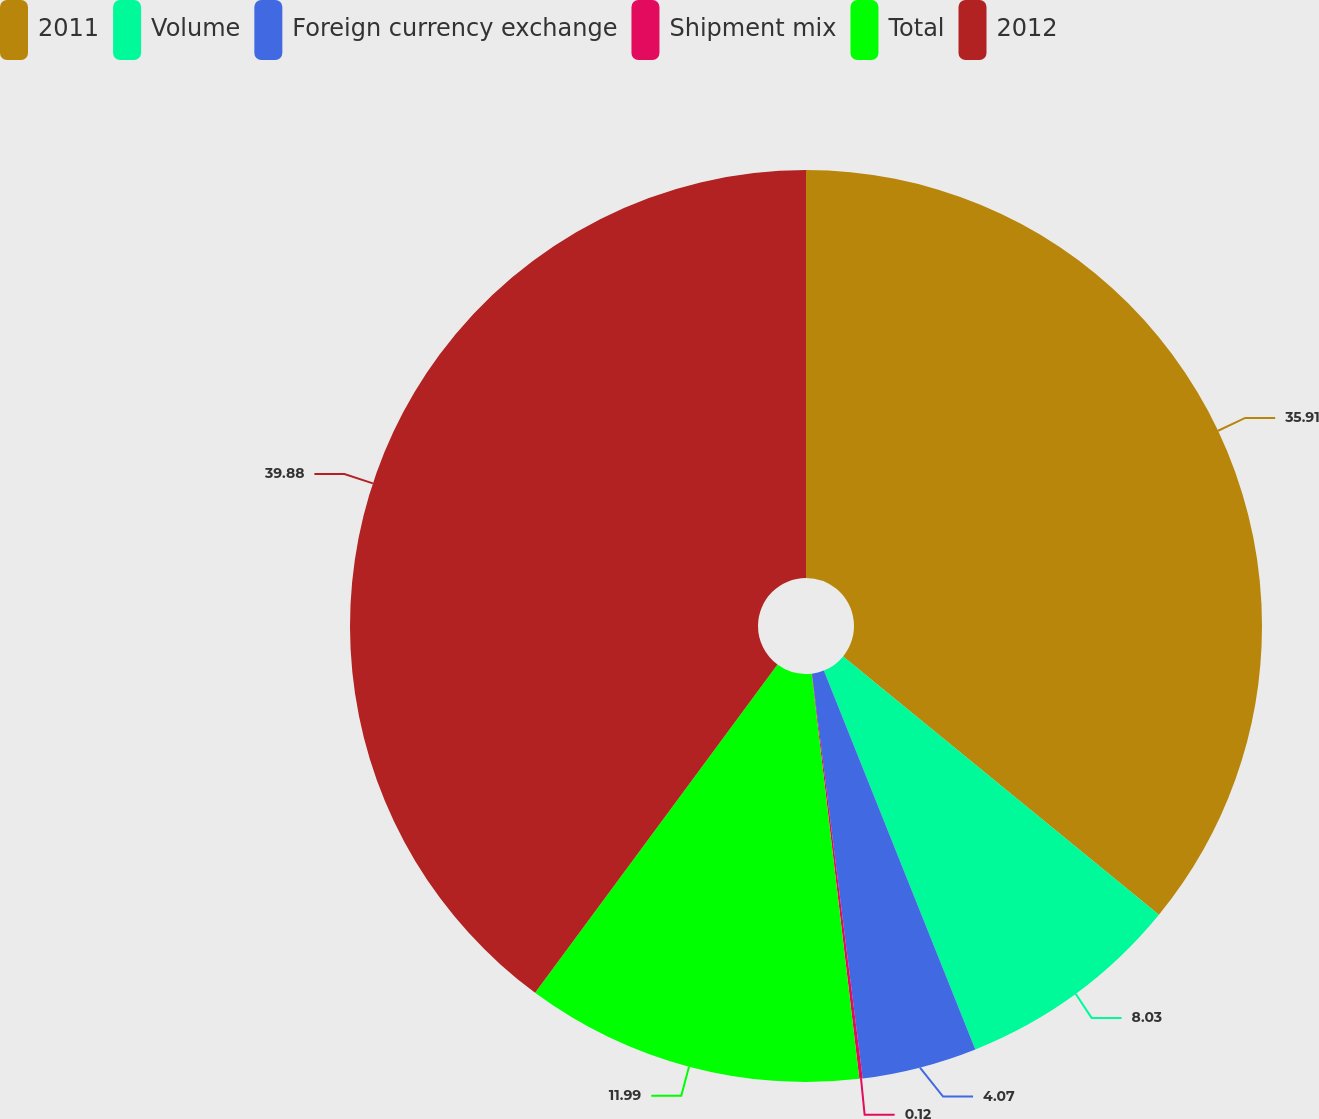Convert chart. <chart><loc_0><loc_0><loc_500><loc_500><pie_chart><fcel>2011<fcel>Volume<fcel>Foreign currency exchange<fcel>Shipment mix<fcel>Total<fcel>2012<nl><fcel>35.91%<fcel>8.03%<fcel>4.07%<fcel>0.12%<fcel>11.99%<fcel>39.87%<nl></chart> 